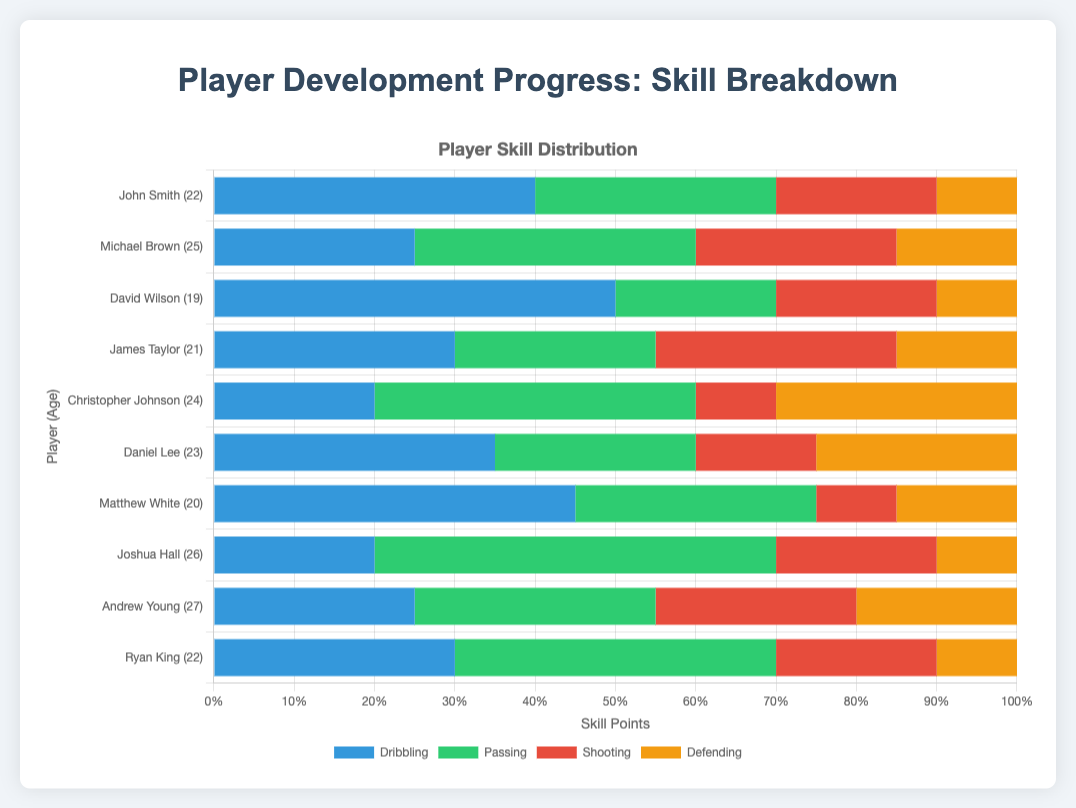Who has the highest dribbling skill value among the players? To find this, look at the lengths of the blue bars representing dribbling skill for each player. Find the longest blue bar. John Smith and David Wilson both have the longest blue bars indicating the highest dribbling value of 50.
Answer: John Smith and David Wilson Which player has the greatest total skill points? Calculate the sum of dribbling, passing, shooting, and defending skill points for each player. Compare the sums to find the highest total. Joshua Hall has the highest total with 100 skill points (20 + 50 + 20 + 10 = 100).
Answer: Joshua Hall Which two players have identical skill distribution for defending? Look at the lengths of the yellow bars representing defending skill for each player. Identify the players whose yellow bars are of the same length. John Smith, David Wilson, Joshua Hall, and Ryan King each have a defending skill of 10.
Answer: John Smith, David Wilson, Joshua Hall, and Ryan King Is there any player whose passing skill is greater than or equal to his dribbling skill? Compare the lengths of the green (passing) and blue (dribbling) bars for each player to see which has a passing skill equal to or greater than the dribbling skill. Joshua Hall has a passing skill (50) greater than his dribbling skill (20).
Answer: Joshua Hall What is the average shooting skill among all players? Sum the shooting skill points of all players and divide by the number of players. (20 + 25 + 20 + 30 + 10 + 15 + 10 + 20 + 25 + 20) / 10 = 19.5
Answer: 19.5 For which team does the player with the highest passing skill play? Find the player with the longest green bar and note their team. Joshua Hall, with a passing skill of 50, plays for Coastline Crusaders.
Answer: Coastline Crusaders How many players have a defending skill of 15? Count the number of yellow bars representing defending skill with a length correlating to 15. Michael Brown, James Taylor, Daniel Lee, and Matthew White each have a defending skill of 15.
Answer: 4 Which player has the largest difference between their dribbling and passing skills? Subtract the passing skill from the dribbling skill for each player and identify the player with the largest absolute difference. David Wilson has the largest difference: 50 (dribbling) - 20 (passing) = 30.
Answer: David Wilson 